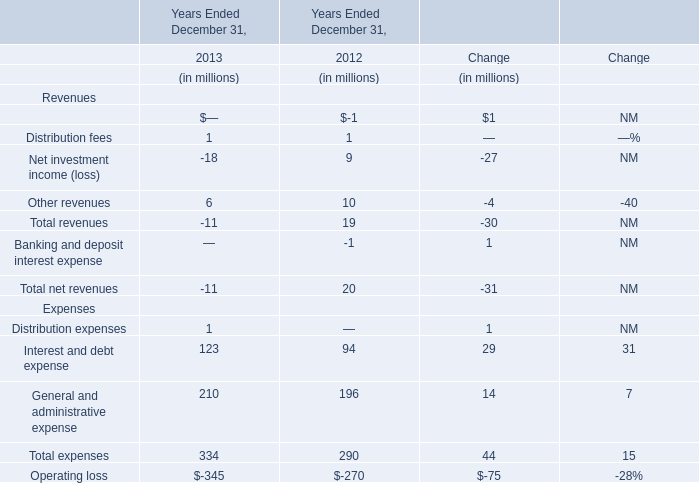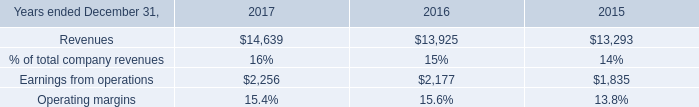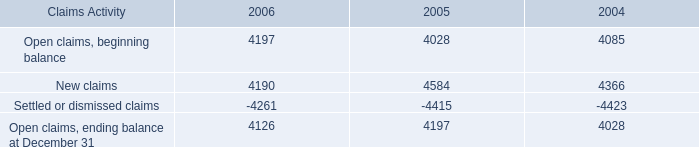What's the sum of New claims of 2005, and Earnings from operations of 2016 ? 
Computations: (4584.0 + 2177.0)
Answer: 6761.0. what was the percentage change in open claims ending balance at december 31 from 2005 to 2006? 
Computations: ((4126 - 4197) / 4197)
Answer: -0.01692. 